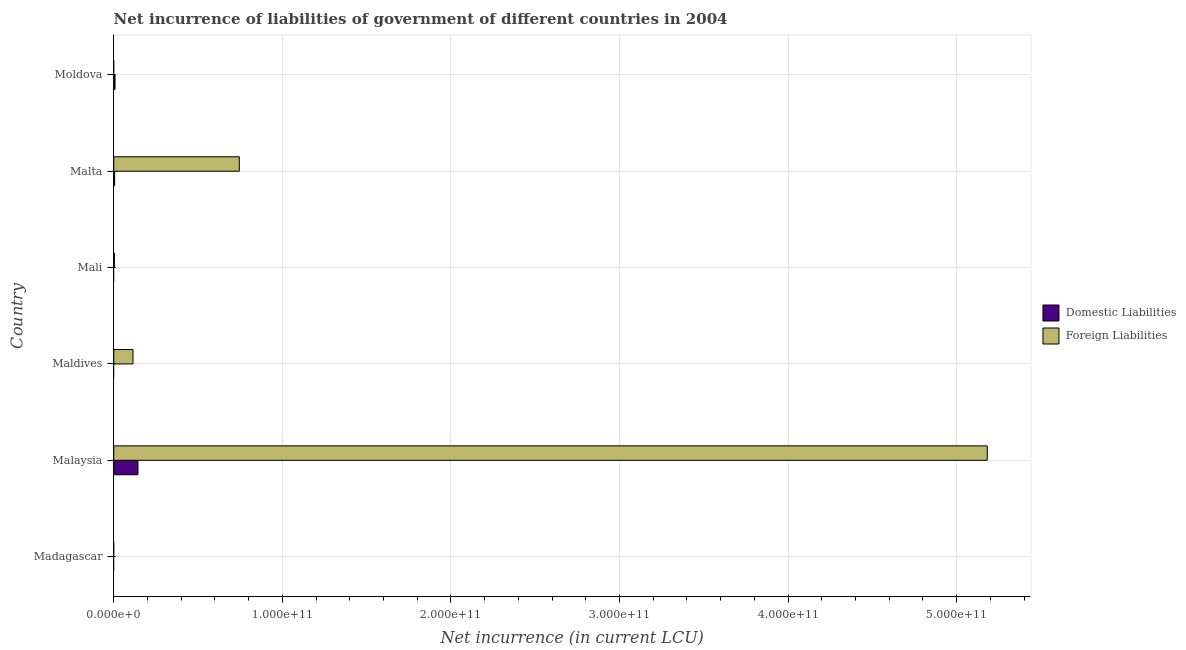How many different coloured bars are there?
Give a very brief answer. 2. Are the number of bars per tick equal to the number of legend labels?
Provide a succinct answer. No. What is the label of the 5th group of bars from the top?
Keep it short and to the point. Malaysia. What is the net incurrence of domestic liabilities in Moldova?
Offer a terse response. 7.78e+08. Across all countries, what is the maximum net incurrence of foreign liabilities?
Your answer should be very brief. 5.18e+11. In which country was the net incurrence of foreign liabilities maximum?
Provide a succinct answer. Malaysia. What is the total net incurrence of domestic liabilities in the graph?
Keep it short and to the point. 1.57e+1. What is the difference between the net incurrence of foreign liabilities in Malaysia and that in Malta?
Provide a short and direct response. 4.44e+11. What is the difference between the net incurrence of domestic liabilities in Mali and the net incurrence of foreign liabilities in Malaysia?
Keep it short and to the point. -5.18e+11. What is the average net incurrence of domestic liabilities per country?
Offer a very short reply. 2.61e+09. What is the difference between the net incurrence of foreign liabilities and net incurrence of domestic liabilities in Malaysia?
Your answer should be compact. 5.04e+11. In how many countries, is the net incurrence of domestic liabilities greater than 60000000000 LCU?
Provide a short and direct response. 0. What is the ratio of the net incurrence of foreign liabilities in Maldives to that in Mali?
Offer a very short reply. 28.27. What is the difference between the highest and the second highest net incurrence of foreign liabilities?
Offer a terse response. 4.44e+11. What is the difference between the highest and the lowest net incurrence of foreign liabilities?
Keep it short and to the point. 5.18e+11. Is the sum of the net incurrence of foreign liabilities in Malaysia and Malta greater than the maximum net incurrence of domestic liabilities across all countries?
Offer a very short reply. Yes. Are all the bars in the graph horizontal?
Your answer should be very brief. Yes. How many countries are there in the graph?
Ensure brevity in your answer.  6. What is the difference between two consecutive major ticks on the X-axis?
Keep it short and to the point. 1.00e+11. How are the legend labels stacked?
Provide a short and direct response. Vertical. What is the title of the graph?
Offer a very short reply. Net incurrence of liabilities of government of different countries in 2004. What is the label or title of the X-axis?
Provide a succinct answer. Net incurrence (in current LCU). What is the Net incurrence (in current LCU) in Domestic Liabilities in Malaysia?
Give a very brief answer. 1.44e+1. What is the Net incurrence (in current LCU) of Foreign Liabilities in Malaysia?
Your answer should be compact. 5.18e+11. What is the Net incurrence (in current LCU) in Foreign Liabilities in Maldives?
Ensure brevity in your answer.  1.14e+1. What is the Net incurrence (in current LCU) of Domestic Liabilities in Mali?
Your response must be concise. 0. What is the Net incurrence (in current LCU) in Foreign Liabilities in Mali?
Your answer should be very brief. 4.04e+08. What is the Net incurrence (in current LCU) of Domestic Liabilities in Malta?
Your answer should be very brief. 5.34e+08. What is the Net incurrence (in current LCU) in Foreign Liabilities in Malta?
Your answer should be compact. 7.45e+1. What is the Net incurrence (in current LCU) of Domestic Liabilities in Moldova?
Provide a short and direct response. 7.78e+08. Across all countries, what is the maximum Net incurrence (in current LCU) in Domestic Liabilities?
Provide a succinct answer. 1.44e+1. Across all countries, what is the maximum Net incurrence (in current LCU) of Foreign Liabilities?
Your answer should be compact. 5.18e+11. Across all countries, what is the minimum Net incurrence (in current LCU) of Domestic Liabilities?
Give a very brief answer. 0. Across all countries, what is the minimum Net incurrence (in current LCU) in Foreign Liabilities?
Keep it short and to the point. 0. What is the total Net incurrence (in current LCU) of Domestic Liabilities in the graph?
Keep it short and to the point. 1.57e+1. What is the total Net incurrence (in current LCU) of Foreign Liabilities in the graph?
Provide a short and direct response. 6.05e+11. What is the difference between the Net incurrence (in current LCU) of Foreign Liabilities in Malaysia and that in Maldives?
Your answer should be compact. 5.07e+11. What is the difference between the Net incurrence (in current LCU) in Foreign Liabilities in Malaysia and that in Mali?
Ensure brevity in your answer.  5.18e+11. What is the difference between the Net incurrence (in current LCU) in Domestic Liabilities in Malaysia and that in Malta?
Your response must be concise. 1.38e+1. What is the difference between the Net incurrence (in current LCU) in Foreign Liabilities in Malaysia and that in Malta?
Your answer should be very brief. 4.44e+11. What is the difference between the Net incurrence (in current LCU) of Domestic Liabilities in Malaysia and that in Moldova?
Offer a terse response. 1.36e+1. What is the difference between the Net incurrence (in current LCU) of Foreign Liabilities in Maldives and that in Mali?
Ensure brevity in your answer.  1.10e+1. What is the difference between the Net incurrence (in current LCU) in Foreign Liabilities in Maldives and that in Malta?
Offer a very short reply. -6.31e+1. What is the difference between the Net incurrence (in current LCU) of Foreign Liabilities in Mali and that in Malta?
Your answer should be compact. -7.41e+1. What is the difference between the Net incurrence (in current LCU) of Domestic Liabilities in Malta and that in Moldova?
Give a very brief answer. -2.45e+08. What is the difference between the Net incurrence (in current LCU) of Domestic Liabilities in Malaysia and the Net incurrence (in current LCU) of Foreign Liabilities in Maldives?
Ensure brevity in your answer.  2.95e+09. What is the difference between the Net incurrence (in current LCU) of Domestic Liabilities in Malaysia and the Net incurrence (in current LCU) of Foreign Liabilities in Mali?
Make the answer very short. 1.40e+1. What is the difference between the Net incurrence (in current LCU) of Domestic Liabilities in Malaysia and the Net incurrence (in current LCU) of Foreign Liabilities in Malta?
Your answer should be compact. -6.01e+1. What is the average Net incurrence (in current LCU) of Domestic Liabilities per country?
Provide a short and direct response. 2.61e+09. What is the average Net incurrence (in current LCU) in Foreign Liabilities per country?
Give a very brief answer. 1.01e+11. What is the difference between the Net incurrence (in current LCU) of Domestic Liabilities and Net incurrence (in current LCU) of Foreign Liabilities in Malaysia?
Offer a terse response. -5.04e+11. What is the difference between the Net incurrence (in current LCU) of Domestic Liabilities and Net incurrence (in current LCU) of Foreign Liabilities in Malta?
Your answer should be very brief. -7.40e+1. What is the ratio of the Net incurrence (in current LCU) in Foreign Liabilities in Malaysia to that in Maldives?
Provide a short and direct response. 45.41. What is the ratio of the Net incurrence (in current LCU) in Foreign Liabilities in Malaysia to that in Mali?
Your answer should be compact. 1283.63. What is the ratio of the Net incurrence (in current LCU) in Domestic Liabilities in Malaysia to that in Malta?
Provide a succinct answer. 26.91. What is the ratio of the Net incurrence (in current LCU) in Foreign Liabilities in Malaysia to that in Malta?
Give a very brief answer. 6.96. What is the ratio of the Net incurrence (in current LCU) in Domestic Liabilities in Malaysia to that in Moldova?
Offer a terse response. 18.44. What is the ratio of the Net incurrence (in current LCU) in Foreign Liabilities in Maldives to that in Mali?
Give a very brief answer. 28.27. What is the ratio of the Net incurrence (in current LCU) of Foreign Liabilities in Maldives to that in Malta?
Offer a terse response. 0.15. What is the ratio of the Net incurrence (in current LCU) of Foreign Liabilities in Mali to that in Malta?
Make the answer very short. 0.01. What is the ratio of the Net incurrence (in current LCU) in Domestic Liabilities in Malta to that in Moldova?
Offer a terse response. 0.69. What is the difference between the highest and the second highest Net incurrence (in current LCU) in Domestic Liabilities?
Your answer should be compact. 1.36e+1. What is the difference between the highest and the second highest Net incurrence (in current LCU) of Foreign Liabilities?
Offer a terse response. 4.44e+11. What is the difference between the highest and the lowest Net incurrence (in current LCU) of Domestic Liabilities?
Keep it short and to the point. 1.44e+1. What is the difference between the highest and the lowest Net incurrence (in current LCU) in Foreign Liabilities?
Your answer should be compact. 5.18e+11. 